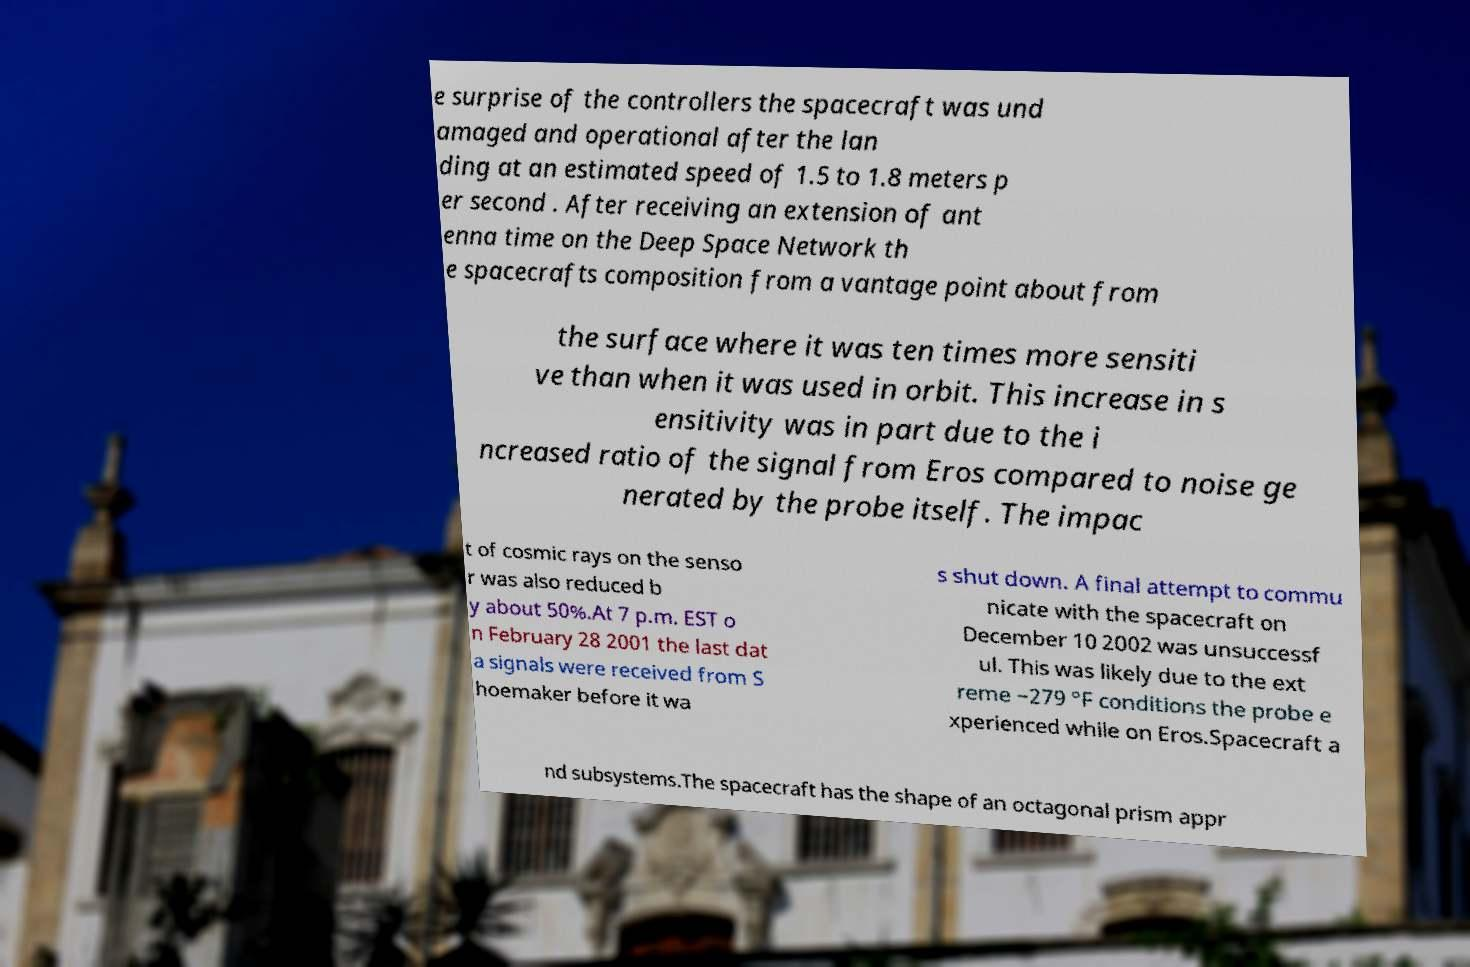Could you assist in decoding the text presented in this image and type it out clearly? e surprise of the controllers the spacecraft was und amaged and operational after the lan ding at an estimated speed of 1.5 to 1.8 meters p er second . After receiving an extension of ant enna time on the Deep Space Network th e spacecrafts composition from a vantage point about from the surface where it was ten times more sensiti ve than when it was used in orbit. This increase in s ensitivity was in part due to the i ncreased ratio of the signal from Eros compared to noise ge nerated by the probe itself. The impac t of cosmic rays on the senso r was also reduced b y about 50%.At 7 p.m. EST o n February 28 2001 the last dat a signals were received from S hoemaker before it wa s shut down. A final attempt to commu nicate with the spacecraft on December 10 2002 was unsuccessf ul. This was likely due to the ext reme −279 °F conditions the probe e xperienced while on Eros.Spacecraft a nd subsystems.The spacecraft has the shape of an octagonal prism appr 